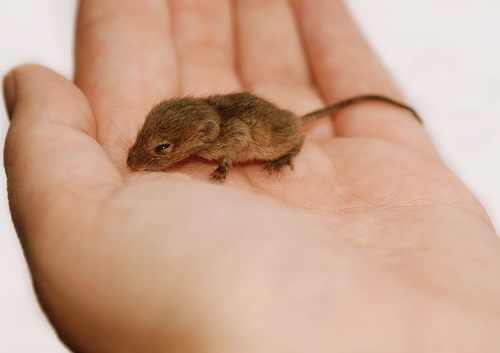<image>
Is the thumb under the mouse? No. The thumb is not positioned under the mouse. The vertical relationship between these objects is different. 